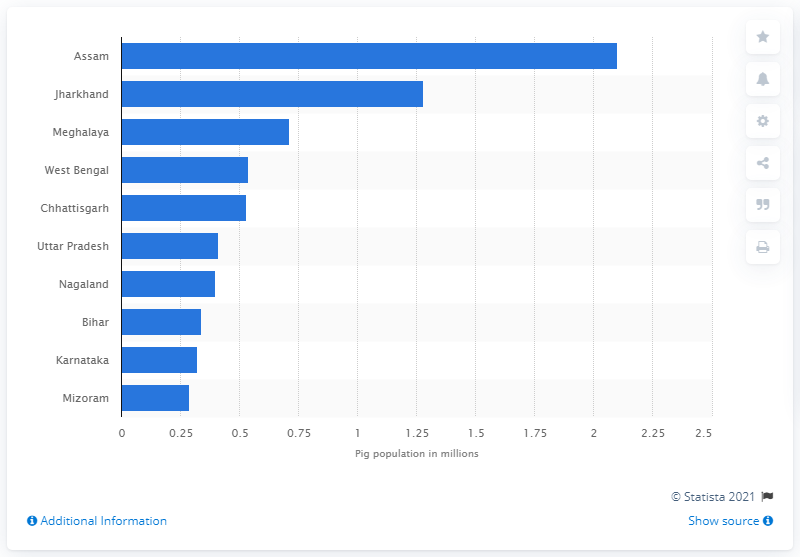Mention a couple of crucial points in this snapshot. According to data from 2019, Jharkhand had the highest pig population among all states in India. The state of Assam had the highest pig population in India in 2019. In 2019, the state of Meghalaya had the highest pig population in India. 